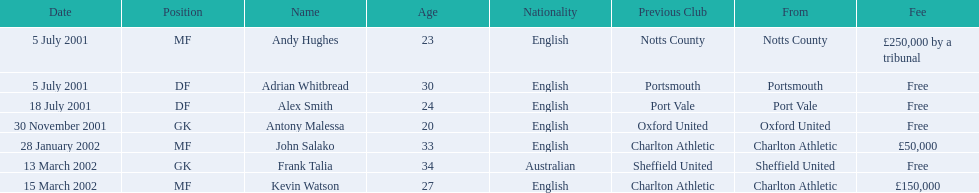What are the names of all the players? Andy Hughes, Adrian Whitbread, Alex Smith, Antony Malessa, John Salako, Frank Talia, Kevin Watson. What fee did andy hughes command? £250,000 by a tribunal. What fee did john salako command? £50,000. Which player had the highest fee, andy hughes or john salako? Andy Hughes. 